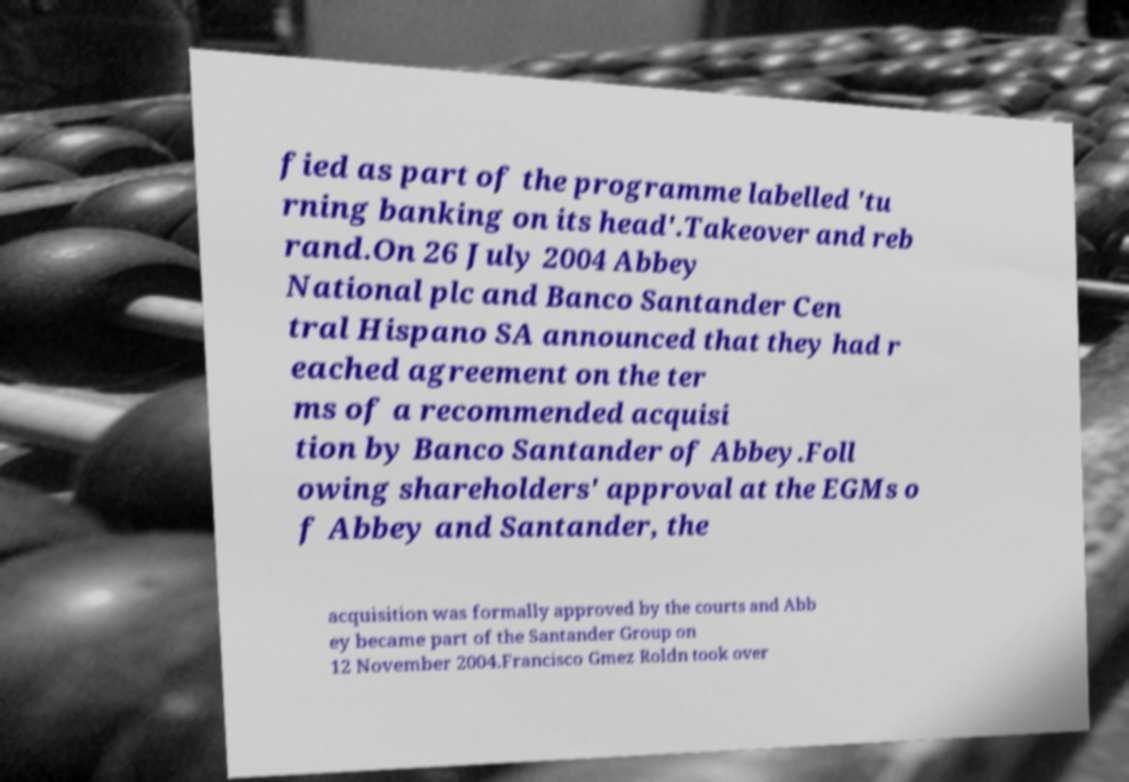What messages or text are displayed in this image? I need them in a readable, typed format. fied as part of the programme labelled 'tu rning banking on its head'.Takeover and reb rand.On 26 July 2004 Abbey National plc and Banco Santander Cen tral Hispano SA announced that they had r eached agreement on the ter ms of a recommended acquisi tion by Banco Santander of Abbey.Foll owing shareholders' approval at the EGMs o f Abbey and Santander, the acquisition was formally approved by the courts and Abb ey became part of the Santander Group on 12 November 2004.Francisco Gmez Roldn took over 